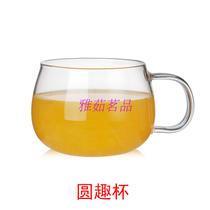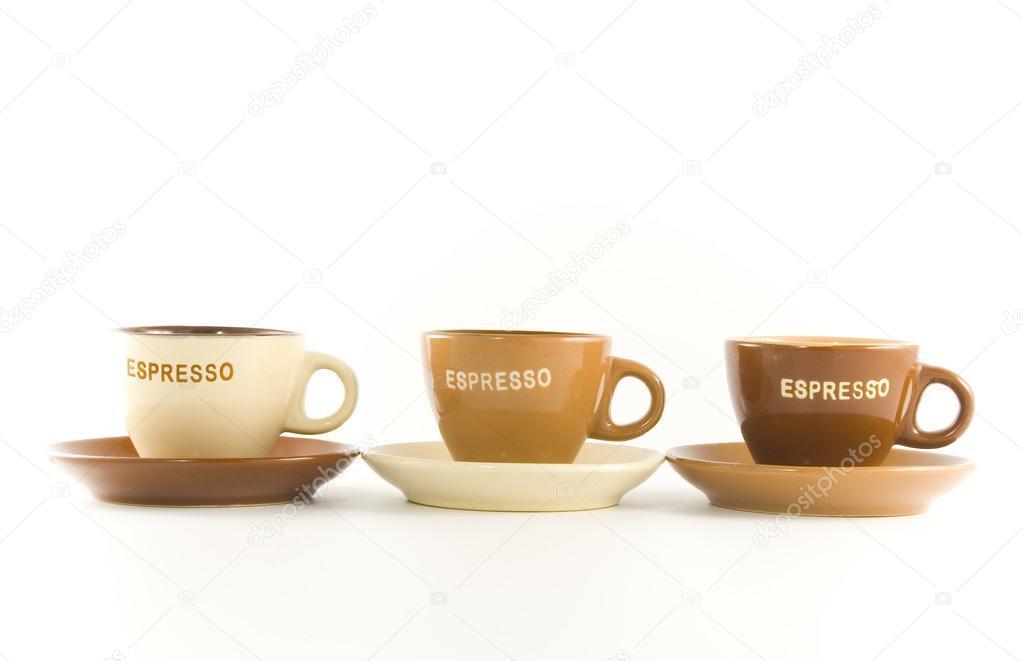The first image is the image on the left, the second image is the image on the right. Given the left and right images, does the statement "There are exactly three cups in each image in the pair." hold true? Answer yes or no. No. The first image is the image on the left, the second image is the image on the right. Given the left and right images, does the statement "An image shows exactly cups with white exteriors." hold true? Answer yes or no. No. 